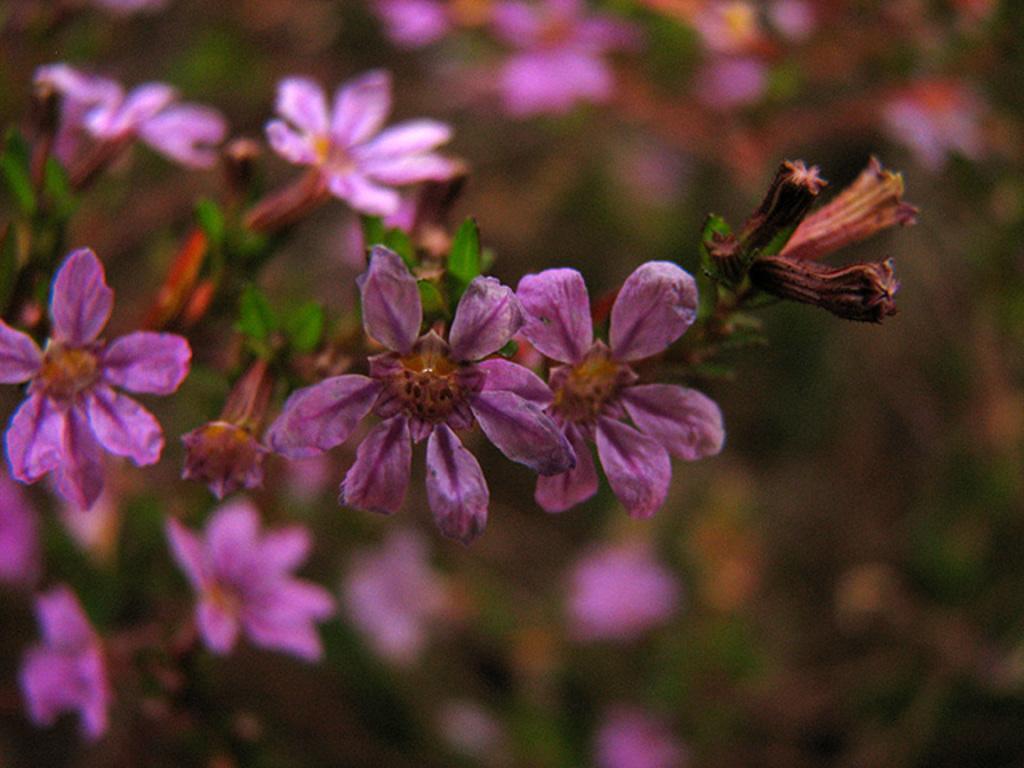Describe this image in one or two sentences. In the picture we can see a plant with violet colored flowers and behind it, we can see some plants which are not clearly visible. 